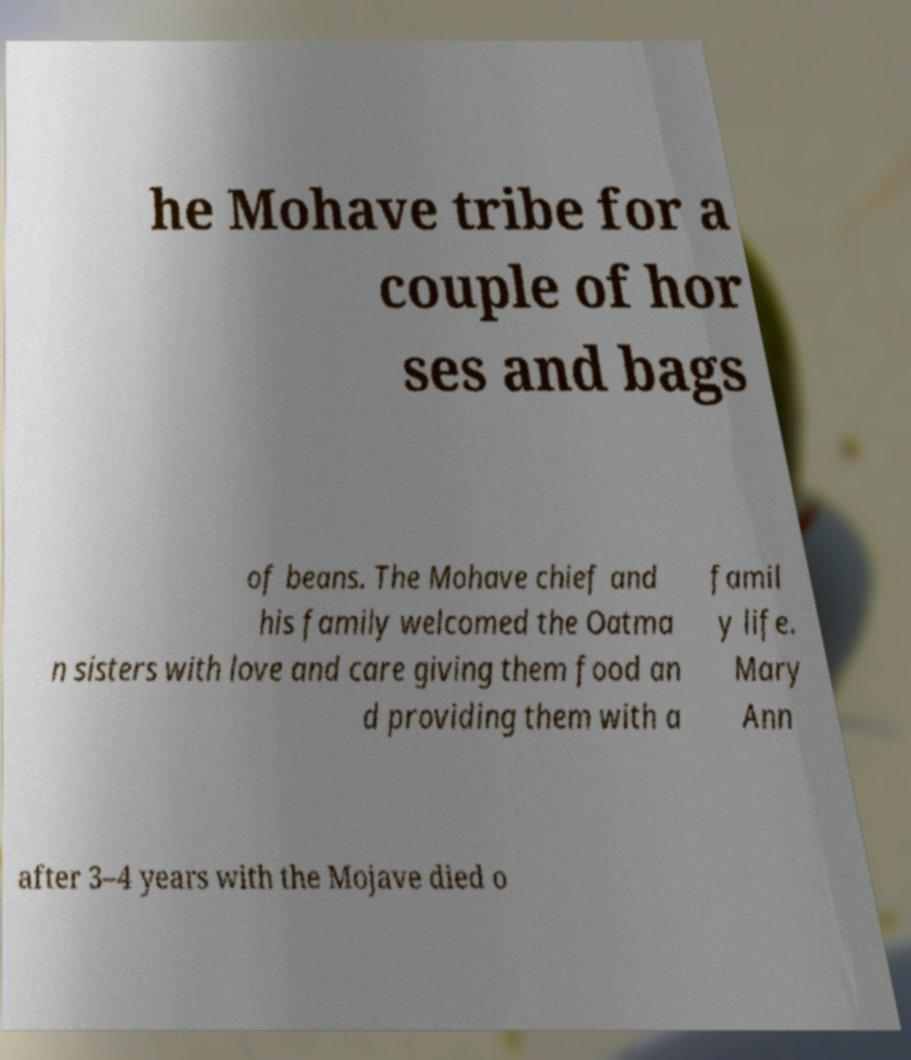There's text embedded in this image that I need extracted. Can you transcribe it verbatim? he Mohave tribe for a couple of hor ses and bags of beans. The Mohave chief and his family welcomed the Oatma n sisters with love and care giving them food an d providing them with a famil y life. Mary Ann after 3–4 years with the Mojave died o 